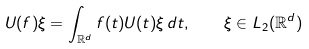Convert formula to latex. <formula><loc_0><loc_0><loc_500><loc_500>U ( f ) \xi = \int _ { { \mathbb { R } } ^ { d } } f ( t ) U ( t ) \xi \, d t , \quad \xi \in L _ { 2 } ( { \mathbb { R } } ^ { d } )</formula> 